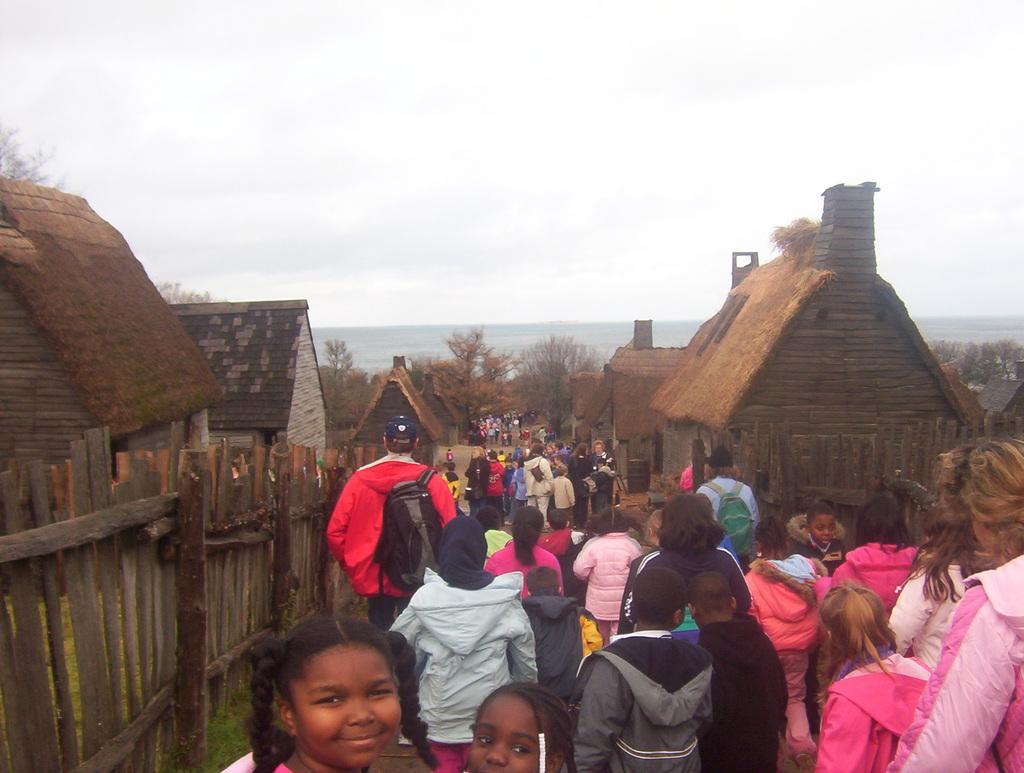Please provide a concise description of this image. In the picture we can see many people are walking on the path on the either sides of the path we can see wooden railings and houses and huts behind them and in the background we can see trees, hills and sky with clouds. 